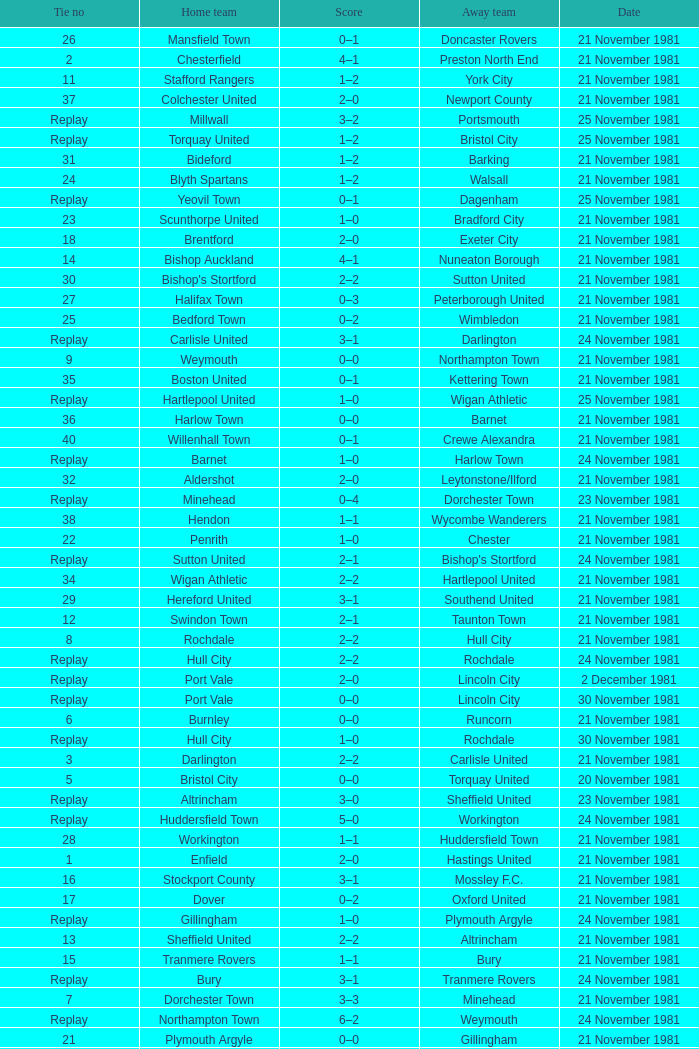On what date was tie number 4? 21 November 1981. Write the full table. {'header': ['Tie no', 'Home team', 'Score', 'Away team', 'Date'], 'rows': [['26', 'Mansfield Town', '0–1', 'Doncaster Rovers', '21 November 1981'], ['2', 'Chesterfield', '4–1', 'Preston North End', '21 November 1981'], ['11', 'Stafford Rangers', '1–2', 'York City', '21 November 1981'], ['37', 'Colchester United', '2–0', 'Newport County', '21 November 1981'], ['Replay', 'Millwall', '3–2', 'Portsmouth', '25 November 1981'], ['Replay', 'Torquay United', '1–2', 'Bristol City', '25 November 1981'], ['31', 'Bideford', '1–2', 'Barking', '21 November 1981'], ['24', 'Blyth Spartans', '1–2', 'Walsall', '21 November 1981'], ['Replay', 'Yeovil Town', '0–1', 'Dagenham', '25 November 1981'], ['23', 'Scunthorpe United', '1–0', 'Bradford City', '21 November 1981'], ['18', 'Brentford', '2–0', 'Exeter City', '21 November 1981'], ['14', 'Bishop Auckland', '4–1', 'Nuneaton Borough', '21 November 1981'], ['30', "Bishop's Stortford", '2–2', 'Sutton United', '21 November 1981'], ['27', 'Halifax Town', '0–3', 'Peterborough United', '21 November 1981'], ['25', 'Bedford Town', '0–2', 'Wimbledon', '21 November 1981'], ['Replay', 'Carlisle United', '3–1', 'Darlington', '24 November 1981'], ['9', 'Weymouth', '0–0', 'Northampton Town', '21 November 1981'], ['35', 'Boston United', '0–1', 'Kettering Town', '21 November 1981'], ['Replay', 'Hartlepool United', '1–0', 'Wigan Athletic', '25 November 1981'], ['36', 'Harlow Town', '0–0', 'Barnet', '21 November 1981'], ['40', 'Willenhall Town', '0–1', 'Crewe Alexandra', '21 November 1981'], ['Replay', 'Barnet', '1–0', 'Harlow Town', '24 November 1981'], ['32', 'Aldershot', '2–0', 'Leytonstone/Ilford', '21 November 1981'], ['Replay', 'Minehead', '0–4', 'Dorchester Town', '23 November 1981'], ['38', 'Hendon', '1–1', 'Wycombe Wanderers', '21 November 1981'], ['22', 'Penrith', '1–0', 'Chester', '21 November 1981'], ['Replay', 'Sutton United', '2–1', "Bishop's Stortford", '24 November 1981'], ['34', 'Wigan Athletic', '2–2', 'Hartlepool United', '21 November 1981'], ['29', 'Hereford United', '3–1', 'Southend United', '21 November 1981'], ['12', 'Swindon Town', '2–1', 'Taunton Town', '21 November 1981'], ['8', 'Rochdale', '2–2', 'Hull City', '21 November 1981'], ['Replay', 'Hull City', '2–2', 'Rochdale', '24 November 1981'], ['Replay', 'Port Vale', '2–0', 'Lincoln City', '2 December 1981'], ['Replay', 'Port Vale', '0–0', 'Lincoln City', '30 November 1981'], ['6', 'Burnley', '0–0', 'Runcorn', '21 November 1981'], ['Replay', 'Hull City', '1–0', 'Rochdale', '30 November 1981'], ['3', 'Darlington', '2–2', 'Carlisle United', '21 November 1981'], ['5', 'Bristol City', '0–0', 'Torquay United', '20 November 1981'], ['Replay', 'Altrincham', '3–0', 'Sheffield United', '23 November 1981'], ['Replay', 'Huddersfield Town', '5–0', 'Workington', '24 November 1981'], ['28', 'Workington', '1–1', 'Huddersfield Town', '21 November 1981'], ['1', 'Enfield', '2–0', 'Hastings United', '21 November 1981'], ['16', 'Stockport County', '3–1', 'Mossley F.C.', '21 November 1981'], ['17', 'Dover', '0–2', 'Oxford United', '21 November 1981'], ['Replay', 'Gillingham', '1–0', 'Plymouth Argyle', '24 November 1981'], ['13', 'Sheffield United', '2–2', 'Altrincham', '21 November 1981'], ['15', 'Tranmere Rovers', '1–1', 'Bury', '21 November 1981'], ['Replay', 'Bury', '3–1', 'Tranmere Rovers', '24 November 1981'], ['7', 'Dorchester Town', '3–3', 'Minehead', '21 November 1981'], ['Replay', 'Northampton Town', '6–2', 'Weymouth', '24 November 1981'], ['21', 'Plymouth Argyle', '0–0', 'Gillingham', '21 November 1981'], ['10', 'Lincoln City', '2–2', 'Port Vale', '21 November 1981'], ['Replay', 'Runcorn', '1–2', 'Burnley', '24 November 1981'], ['4', 'Bournemouth', '1–0', 'Reading', '21 November 1981'], ['39', 'Dagenham', '2–2', 'Yeovil Town', '21 November 1981'], ['19', 'Bristol Rovers', '1–2', 'Fulham', '21 November 1981'], ['Replay', 'Wycombe Wanderers', '2–0', 'Hendon', '24 November 1981'], ['20', 'Portsmouth', '1–1', 'Millwall', '21 November 1981'], ['33', 'Horden CW', '0–1', 'Blackpool', '21 November 1981']]} 